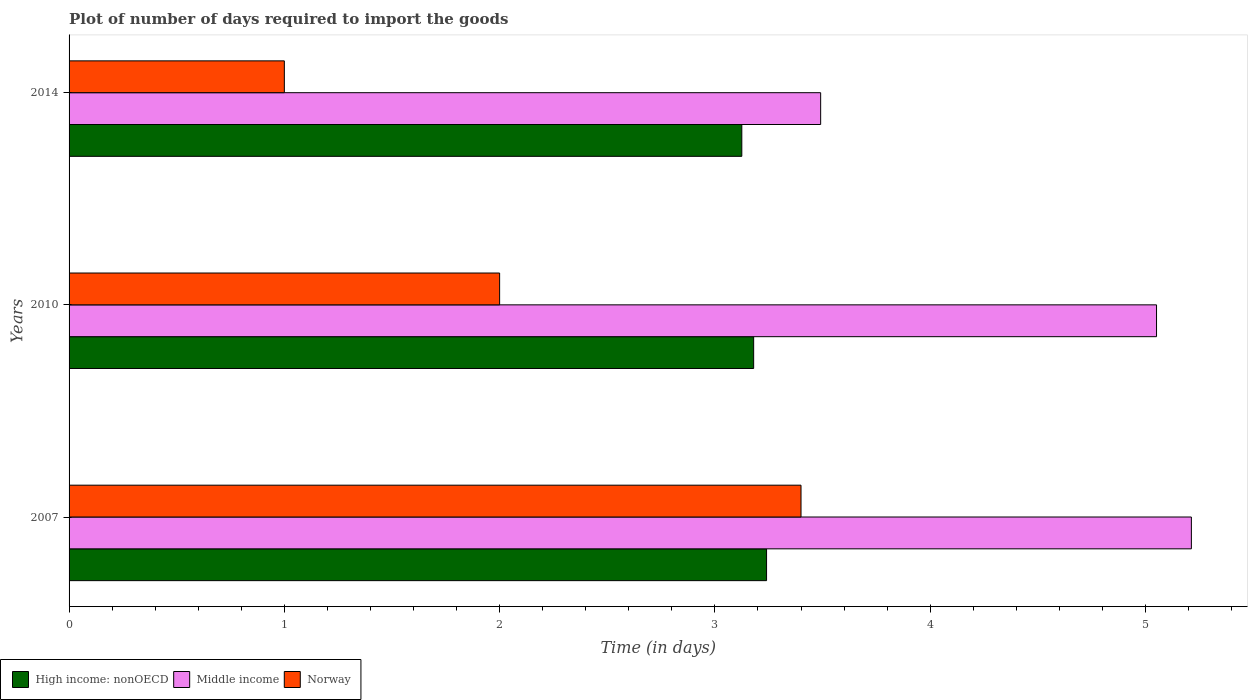Are the number of bars on each tick of the Y-axis equal?
Offer a very short reply. Yes. What is the label of the 3rd group of bars from the top?
Your response must be concise. 2007. What is the time required to import goods in High income: nonOECD in 2014?
Keep it short and to the point. 3.12. Across all years, what is the maximum time required to import goods in Middle income?
Your response must be concise. 5.21. Across all years, what is the minimum time required to import goods in High income: nonOECD?
Provide a succinct answer. 3.12. What is the total time required to import goods in High income: nonOECD in the graph?
Make the answer very short. 9.54. What is the difference between the time required to import goods in Norway in 2007 and that in 2010?
Offer a very short reply. 1.4. What is the difference between the time required to import goods in High income: nonOECD in 2010 and the time required to import goods in Middle income in 2007?
Offer a terse response. -2.03. What is the average time required to import goods in High income: nonOECD per year?
Offer a very short reply. 3.18. In the year 2014, what is the difference between the time required to import goods in High income: nonOECD and time required to import goods in Middle income?
Your response must be concise. -0.37. What is the ratio of the time required to import goods in High income: nonOECD in 2010 to that in 2014?
Offer a terse response. 1.02. Is the time required to import goods in Norway in 2007 less than that in 2014?
Your response must be concise. No. Is the difference between the time required to import goods in High income: nonOECD in 2007 and 2010 greater than the difference between the time required to import goods in Middle income in 2007 and 2010?
Your answer should be compact. No. What is the difference between the highest and the second highest time required to import goods in Middle income?
Your answer should be compact. 0.16. What is the difference between the highest and the lowest time required to import goods in Middle income?
Provide a short and direct response. 1.72. In how many years, is the time required to import goods in Norway greater than the average time required to import goods in Norway taken over all years?
Make the answer very short. 1. What does the 3rd bar from the top in 2010 represents?
Make the answer very short. High income: nonOECD. What does the 3rd bar from the bottom in 2007 represents?
Your response must be concise. Norway. How many bars are there?
Ensure brevity in your answer.  9. Are all the bars in the graph horizontal?
Your answer should be compact. Yes. How many years are there in the graph?
Your response must be concise. 3. Are the values on the major ticks of X-axis written in scientific E-notation?
Your answer should be very brief. No. Does the graph contain any zero values?
Provide a succinct answer. No. What is the title of the graph?
Keep it short and to the point. Plot of number of days required to import the goods. Does "Dominica" appear as one of the legend labels in the graph?
Provide a short and direct response. No. What is the label or title of the X-axis?
Your response must be concise. Time (in days). What is the Time (in days) in High income: nonOECD in 2007?
Your answer should be very brief. 3.24. What is the Time (in days) of Middle income in 2007?
Provide a succinct answer. 5.21. What is the Time (in days) of Norway in 2007?
Make the answer very short. 3.4. What is the Time (in days) of High income: nonOECD in 2010?
Your answer should be compact. 3.18. What is the Time (in days) of Middle income in 2010?
Your answer should be compact. 5.05. What is the Time (in days) in Norway in 2010?
Provide a succinct answer. 2. What is the Time (in days) of High income: nonOECD in 2014?
Provide a succinct answer. 3.12. What is the Time (in days) of Middle income in 2014?
Keep it short and to the point. 3.49. Across all years, what is the maximum Time (in days) of High income: nonOECD?
Provide a succinct answer. 3.24. Across all years, what is the maximum Time (in days) in Middle income?
Provide a succinct answer. 5.21. Across all years, what is the maximum Time (in days) of Norway?
Make the answer very short. 3.4. Across all years, what is the minimum Time (in days) in High income: nonOECD?
Make the answer very short. 3.12. Across all years, what is the minimum Time (in days) in Middle income?
Your response must be concise. 3.49. What is the total Time (in days) of High income: nonOECD in the graph?
Keep it short and to the point. 9.54. What is the total Time (in days) of Middle income in the graph?
Provide a short and direct response. 13.76. What is the difference between the Time (in days) of High income: nonOECD in 2007 and that in 2010?
Give a very brief answer. 0.06. What is the difference between the Time (in days) of Middle income in 2007 and that in 2010?
Your response must be concise. 0.16. What is the difference between the Time (in days) in Norway in 2007 and that in 2010?
Provide a short and direct response. 1.4. What is the difference between the Time (in days) of High income: nonOECD in 2007 and that in 2014?
Your answer should be compact. 0.12. What is the difference between the Time (in days) in Middle income in 2007 and that in 2014?
Your response must be concise. 1.72. What is the difference between the Time (in days) in Norway in 2007 and that in 2014?
Keep it short and to the point. 2.4. What is the difference between the Time (in days) in High income: nonOECD in 2010 and that in 2014?
Provide a succinct answer. 0.06. What is the difference between the Time (in days) of Middle income in 2010 and that in 2014?
Provide a succinct answer. 1.56. What is the difference between the Time (in days) in Norway in 2010 and that in 2014?
Offer a terse response. 1. What is the difference between the Time (in days) of High income: nonOECD in 2007 and the Time (in days) of Middle income in 2010?
Provide a succinct answer. -1.81. What is the difference between the Time (in days) in High income: nonOECD in 2007 and the Time (in days) in Norway in 2010?
Your answer should be very brief. 1.24. What is the difference between the Time (in days) of Middle income in 2007 and the Time (in days) of Norway in 2010?
Give a very brief answer. 3.21. What is the difference between the Time (in days) of High income: nonOECD in 2007 and the Time (in days) of Middle income in 2014?
Give a very brief answer. -0.25. What is the difference between the Time (in days) of High income: nonOECD in 2007 and the Time (in days) of Norway in 2014?
Your answer should be compact. 2.24. What is the difference between the Time (in days) in Middle income in 2007 and the Time (in days) in Norway in 2014?
Provide a succinct answer. 4.21. What is the difference between the Time (in days) in High income: nonOECD in 2010 and the Time (in days) in Middle income in 2014?
Offer a terse response. -0.31. What is the difference between the Time (in days) in High income: nonOECD in 2010 and the Time (in days) in Norway in 2014?
Offer a very short reply. 2.18. What is the difference between the Time (in days) in Middle income in 2010 and the Time (in days) in Norway in 2014?
Provide a short and direct response. 4.05. What is the average Time (in days) in High income: nonOECD per year?
Provide a short and direct response. 3.18. What is the average Time (in days) of Middle income per year?
Offer a terse response. 4.59. What is the average Time (in days) in Norway per year?
Your answer should be very brief. 2.13. In the year 2007, what is the difference between the Time (in days) in High income: nonOECD and Time (in days) in Middle income?
Make the answer very short. -1.97. In the year 2007, what is the difference between the Time (in days) in High income: nonOECD and Time (in days) in Norway?
Offer a terse response. -0.16. In the year 2007, what is the difference between the Time (in days) of Middle income and Time (in days) of Norway?
Offer a terse response. 1.81. In the year 2010, what is the difference between the Time (in days) of High income: nonOECD and Time (in days) of Middle income?
Give a very brief answer. -1.87. In the year 2010, what is the difference between the Time (in days) in High income: nonOECD and Time (in days) in Norway?
Offer a terse response. 1.18. In the year 2010, what is the difference between the Time (in days) in Middle income and Time (in days) in Norway?
Keep it short and to the point. 3.05. In the year 2014, what is the difference between the Time (in days) of High income: nonOECD and Time (in days) of Middle income?
Offer a very short reply. -0.37. In the year 2014, what is the difference between the Time (in days) in High income: nonOECD and Time (in days) in Norway?
Make the answer very short. 2.12. In the year 2014, what is the difference between the Time (in days) of Middle income and Time (in days) of Norway?
Your response must be concise. 2.49. What is the ratio of the Time (in days) of High income: nonOECD in 2007 to that in 2010?
Give a very brief answer. 1.02. What is the ratio of the Time (in days) of Middle income in 2007 to that in 2010?
Provide a succinct answer. 1.03. What is the ratio of the Time (in days) of Norway in 2007 to that in 2010?
Your response must be concise. 1.7. What is the ratio of the Time (in days) in High income: nonOECD in 2007 to that in 2014?
Your response must be concise. 1.04. What is the ratio of the Time (in days) in Middle income in 2007 to that in 2014?
Offer a very short reply. 1.49. What is the ratio of the Time (in days) in Norway in 2007 to that in 2014?
Provide a short and direct response. 3.4. What is the ratio of the Time (in days) of High income: nonOECD in 2010 to that in 2014?
Make the answer very short. 1.02. What is the ratio of the Time (in days) in Middle income in 2010 to that in 2014?
Offer a very short reply. 1.45. What is the ratio of the Time (in days) in Norway in 2010 to that in 2014?
Provide a succinct answer. 2. What is the difference between the highest and the second highest Time (in days) of Middle income?
Your answer should be very brief. 0.16. What is the difference between the highest and the lowest Time (in days) in High income: nonOECD?
Keep it short and to the point. 0.12. What is the difference between the highest and the lowest Time (in days) in Middle income?
Make the answer very short. 1.72. What is the difference between the highest and the lowest Time (in days) of Norway?
Make the answer very short. 2.4. 